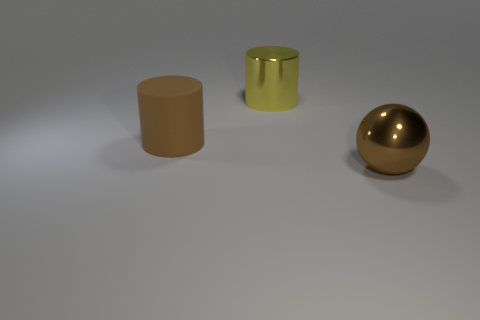What material is the sphere that is the same color as the large matte thing?
Provide a short and direct response. Metal. There is a yellow cylinder that is the same size as the brown sphere; what material is it?
Offer a very short reply. Metal. What material is the big brown thing that is right of the large metal thing that is to the left of the large ball to the right of the large brown matte thing?
Your response must be concise. Metal. There is a metal object that is behind the brown ball; is it the same size as the big brown metallic object?
Your answer should be compact. Yes. Are there more rubber things than small yellow rubber objects?
Make the answer very short. Yes. What number of big objects are either shiny things or yellow matte balls?
Offer a terse response. 2. What number of other things are the same color as the metallic ball?
Give a very brief answer. 1. How many large brown objects are the same material as the big brown cylinder?
Your answer should be very brief. 0. Is the color of the metal object that is in front of the brown rubber cylinder the same as the rubber thing?
Offer a terse response. Yes. What number of yellow things are rubber blocks or metal cylinders?
Your answer should be compact. 1. 